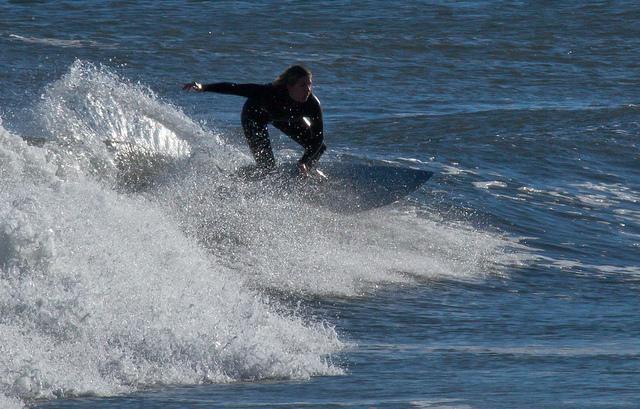What color is the water?
Give a very brief answer. Blue. What color is the surfboard?
Quick response, please. Blue. Is this a lady?
Quick response, please. Yes. Is the penguin swimming?
Give a very brief answer. No. What sport is shown?
Short answer required. Surfing. 